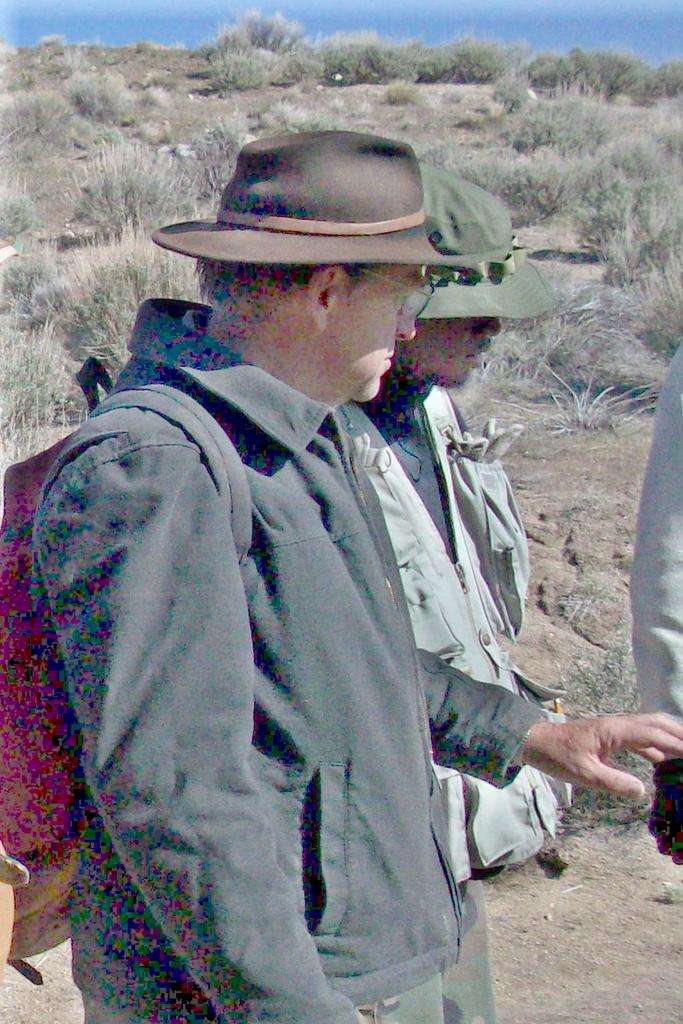How many people are present in the image? There are two men standing in the image. What can be seen in the background of the image? There are bushes in the image. Can you describe any specific detail about one of the men? One of the men is wearing a backpack bag. What part of a person's body is visible on the right side of the image? A person's hand is visible on the right side of the image. What type of fang can be seen in the image? There are no fangs present in the image. What news is being discussed by the two men in the image? The image does not provide any information about what news the two men might be discussing. 